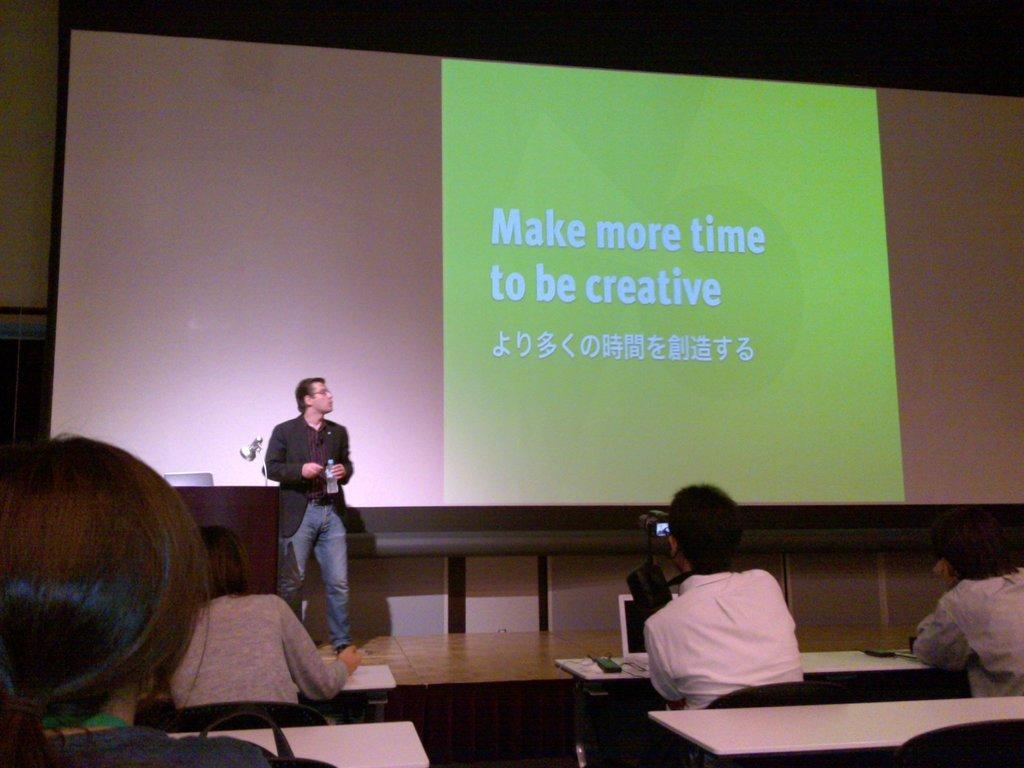<image>
Describe the image concisely. A presenter behind a screen entitled Make more time to be creative. 